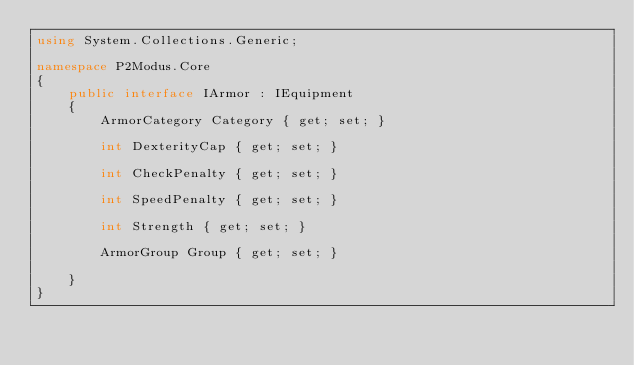Convert code to text. <code><loc_0><loc_0><loc_500><loc_500><_C#_>using System.Collections.Generic;

namespace P2Modus.Core
{
    public interface IArmor : IEquipment
    {
        ArmorCategory Category { get; set; }

        int DexterityCap { get; set; }

        int CheckPenalty { get; set; }

        int SpeedPenalty { get; set; }

        int Strength { get; set; }

        ArmorGroup Group { get; set; }

    }
}</code> 